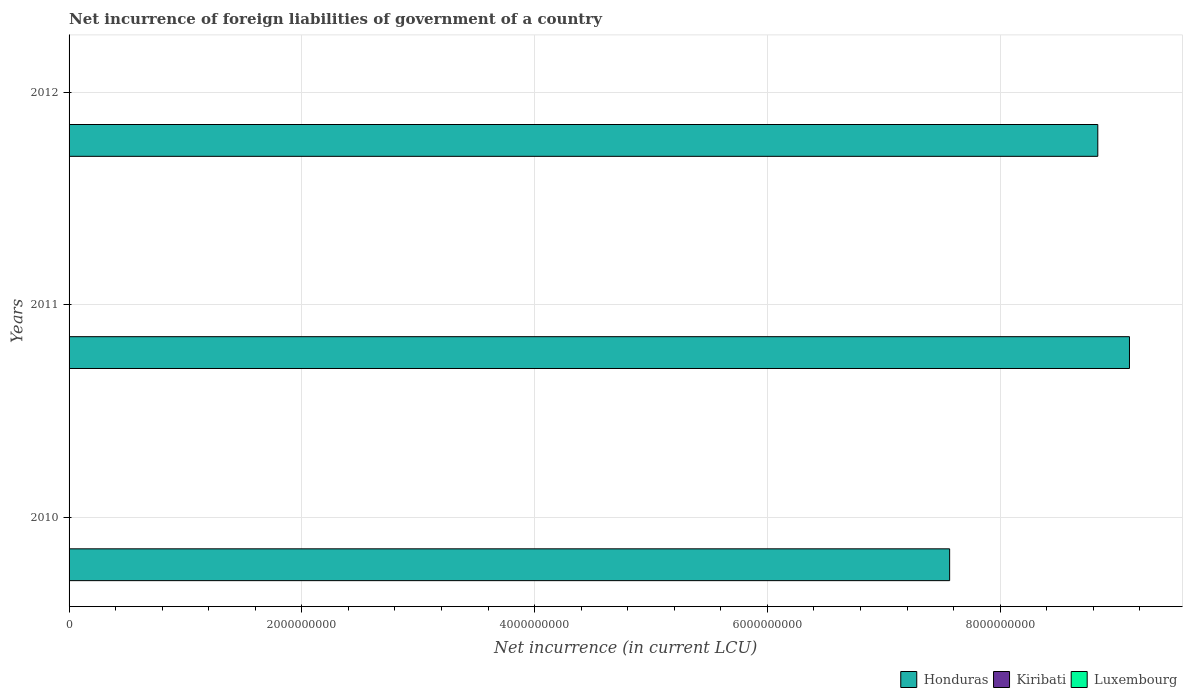How many different coloured bars are there?
Your answer should be very brief. 3. Are the number of bars on each tick of the Y-axis equal?
Provide a succinct answer. Yes. How many bars are there on the 3rd tick from the top?
Keep it short and to the point. 3. What is the net incurrence of foreign liabilities in Kiribati in 2012?
Offer a terse response. 3.40e+05. Across all years, what is the maximum net incurrence of foreign liabilities in Kiribati?
Keep it short and to the point. 3.50e+05. Across all years, what is the minimum net incurrence of foreign liabilities in Kiribati?
Provide a short and direct response. 2.02e+05. In which year was the net incurrence of foreign liabilities in Luxembourg maximum?
Offer a terse response. 2011. What is the total net incurrence of foreign liabilities in Luxembourg in the graph?
Give a very brief answer. 9.31e+06. What is the difference between the net incurrence of foreign liabilities in Honduras in 2010 and that in 2012?
Offer a terse response. -1.27e+09. What is the difference between the net incurrence of foreign liabilities in Honduras in 2010 and the net incurrence of foreign liabilities in Kiribati in 2011?
Keep it short and to the point. 7.57e+09. What is the average net incurrence of foreign liabilities in Luxembourg per year?
Your answer should be compact. 3.10e+06. In the year 2012, what is the difference between the net incurrence of foreign liabilities in Kiribati and net incurrence of foreign liabilities in Luxembourg?
Provide a short and direct response. -2.82e+06. What is the ratio of the net incurrence of foreign liabilities in Kiribati in 2011 to that in 2012?
Your response must be concise. 1.03. Is the net incurrence of foreign liabilities in Kiribati in 2011 less than that in 2012?
Give a very brief answer. No. Is the difference between the net incurrence of foreign liabilities in Kiribati in 2010 and 2011 greater than the difference between the net incurrence of foreign liabilities in Luxembourg in 2010 and 2011?
Offer a very short reply. Yes. What is the difference between the highest and the second highest net incurrence of foreign liabilities in Honduras?
Your answer should be very brief. 2.72e+08. What is the difference between the highest and the lowest net incurrence of foreign liabilities in Kiribati?
Provide a succinct answer. 1.48e+05. In how many years, is the net incurrence of foreign liabilities in Kiribati greater than the average net incurrence of foreign liabilities in Kiribati taken over all years?
Offer a very short reply. 2. Is the sum of the net incurrence of foreign liabilities in Kiribati in 2010 and 2011 greater than the maximum net incurrence of foreign liabilities in Honduras across all years?
Keep it short and to the point. No. What does the 1st bar from the top in 2011 represents?
Offer a very short reply. Luxembourg. What does the 3rd bar from the bottom in 2012 represents?
Keep it short and to the point. Luxembourg. What is the difference between two consecutive major ticks on the X-axis?
Provide a succinct answer. 2.00e+09. Are the values on the major ticks of X-axis written in scientific E-notation?
Your answer should be very brief. No. Does the graph contain any zero values?
Your response must be concise. No. How many legend labels are there?
Ensure brevity in your answer.  3. How are the legend labels stacked?
Make the answer very short. Horizontal. What is the title of the graph?
Make the answer very short. Net incurrence of foreign liabilities of government of a country. Does "Cyprus" appear as one of the legend labels in the graph?
Your answer should be very brief. No. What is the label or title of the X-axis?
Provide a short and direct response. Net incurrence (in current LCU). What is the label or title of the Y-axis?
Keep it short and to the point. Years. What is the Net incurrence (in current LCU) of Honduras in 2010?
Give a very brief answer. 7.57e+09. What is the Net incurrence (in current LCU) in Kiribati in 2010?
Provide a succinct answer. 2.02e+05. What is the Net incurrence (in current LCU) of Honduras in 2011?
Make the answer very short. 9.11e+09. What is the Net incurrence (in current LCU) of Kiribati in 2011?
Provide a short and direct response. 3.50e+05. What is the Net incurrence (in current LCU) in Luxembourg in 2011?
Ensure brevity in your answer.  3.16e+06. What is the Net incurrence (in current LCU) in Honduras in 2012?
Make the answer very short. 8.84e+09. What is the Net incurrence (in current LCU) in Kiribati in 2012?
Give a very brief answer. 3.40e+05. What is the Net incurrence (in current LCU) in Luxembourg in 2012?
Keep it short and to the point. 3.16e+06. Across all years, what is the maximum Net incurrence (in current LCU) in Honduras?
Offer a very short reply. 9.11e+09. Across all years, what is the maximum Net incurrence (in current LCU) in Kiribati?
Offer a very short reply. 3.50e+05. Across all years, what is the maximum Net incurrence (in current LCU) of Luxembourg?
Make the answer very short. 3.16e+06. Across all years, what is the minimum Net incurrence (in current LCU) in Honduras?
Provide a short and direct response. 7.57e+09. Across all years, what is the minimum Net incurrence (in current LCU) of Kiribati?
Keep it short and to the point. 2.02e+05. Across all years, what is the minimum Net incurrence (in current LCU) of Luxembourg?
Your answer should be very brief. 3.00e+06. What is the total Net incurrence (in current LCU) of Honduras in the graph?
Offer a very short reply. 2.55e+1. What is the total Net incurrence (in current LCU) in Kiribati in the graph?
Ensure brevity in your answer.  8.92e+05. What is the total Net incurrence (in current LCU) in Luxembourg in the graph?
Your answer should be very brief. 9.31e+06. What is the difference between the Net incurrence (in current LCU) of Honduras in 2010 and that in 2011?
Your answer should be compact. -1.55e+09. What is the difference between the Net incurrence (in current LCU) of Kiribati in 2010 and that in 2011?
Offer a very short reply. -1.48e+05. What is the difference between the Net incurrence (in current LCU) of Luxembourg in 2010 and that in 2011?
Provide a short and direct response. -1.57e+05. What is the difference between the Net incurrence (in current LCU) of Honduras in 2010 and that in 2012?
Your answer should be very brief. -1.27e+09. What is the difference between the Net incurrence (in current LCU) in Kiribati in 2010 and that in 2012?
Offer a terse response. -1.37e+05. What is the difference between the Net incurrence (in current LCU) in Luxembourg in 2010 and that in 2012?
Ensure brevity in your answer.  -1.57e+05. What is the difference between the Net incurrence (in current LCU) of Honduras in 2011 and that in 2012?
Ensure brevity in your answer.  2.72e+08. What is the difference between the Net incurrence (in current LCU) of Kiribati in 2011 and that in 2012?
Your answer should be compact. 1.02e+04. What is the difference between the Net incurrence (in current LCU) in Luxembourg in 2011 and that in 2012?
Your answer should be very brief. 0. What is the difference between the Net incurrence (in current LCU) in Honduras in 2010 and the Net incurrence (in current LCU) in Kiribati in 2011?
Provide a short and direct response. 7.57e+09. What is the difference between the Net incurrence (in current LCU) of Honduras in 2010 and the Net incurrence (in current LCU) of Luxembourg in 2011?
Offer a terse response. 7.56e+09. What is the difference between the Net incurrence (in current LCU) in Kiribati in 2010 and the Net incurrence (in current LCU) in Luxembourg in 2011?
Offer a terse response. -2.95e+06. What is the difference between the Net incurrence (in current LCU) in Honduras in 2010 and the Net incurrence (in current LCU) in Kiribati in 2012?
Ensure brevity in your answer.  7.57e+09. What is the difference between the Net incurrence (in current LCU) in Honduras in 2010 and the Net incurrence (in current LCU) in Luxembourg in 2012?
Ensure brevity in your answer.  7.56e+09. What is the difference between the Net incurrence (in current LCU) of Kiribati in 2010 and the Net incurrence (in current LCU) of Luxembourg in 2012?
Provide a succinct answer. -2.95e+06. What is the difference between the Net incurrence (in current LCU) of Honduras in 2011 and the Net incurrence (in current LCU) of Kiribati in 2012?
Give a very brief answer. 9.11e+09. What is the difference between the Net incurrence (in current LCU) in Honduras in 2011 and the Net incurrence (in current LCU) in Luxembourg in 2012?
Keep it short and to the point. 9.11e+09. What is the difference between the Net incurrence (in current LCU) of Kiribati in 2011 and the Net incurrence (in current LCU) of Luxembourg in 2012?
Give a very brief answer. -2.81e+06. What is the average Net incurrence (in current LCU) of Honduras per year?
Offer a very short reply. 8.51e+09. What is the average Net incurrence (in current LCU) in Kiribati per year?
Give a very brief answer. 2.97e+05. What is the average Net incurrence (in current LCU) of Luxembourg per year?
Offer a very short reply. 3.10e+06. In the year 2010, what is the difference between the Net incurrence (in current LCU) in Honduras and Net incurrence (in current LCU) in Kiribati?
Ensure brevity in your answer.  7.57e+09. In the year 2010, what is the difference between the Net incurrence (in current LCU) in Honduras and Net incurrence (in current LCU) in Luxembourg?
Give a very brief answer. 7.56e+09. In the year 2010, what is the difference between the Net incurrence (in current LCU) of Kiribati and Net incurrence (in current LCU) of Luxembourg?
Your answer should be compact. -2.80e+06. In the year 2011, what is the difference between the Net incurrence (in current LCU) in Honduras and Net incurrence (in current LCU) in Kiribati?
Make the answer very short. 9.11e+09. In the year 2011, what is the difference between the Net incurrence (in current LCU) in Honduras and Net incurrence (in current LCU) in Luxembourg?
Give a very brief answer. 9.11e+09. In the year 2011, what is the difference between the Net incurrence (in current LCU) in Kiribati and Net incurrence (in current LCU) in Luxembourg?
Offer a terse response. -2.81e+06. In the year 2012, what is the difference between the Net incurrence (in current LCU) in Honduras and Net incurrence (in current LCU) in Kiribati?
Offer a very short reply. 8.84e+09. In the year 2012, what is the difference between the Net incurrence (in current LCU) of Honduras and Net incurrence (in current LCU) of Luxembourg?
Offer a terse response. 8.84e+09. In the year 2012, what is the difference between the Net incurrence (in current LCU) of Kiribati and Net incurrence (in current LCU) of Luxembourg?
Make the answer very short. -2.82e+06. What is the ratio of the Net incurrence (in current LCU) of Honduras in 2010 to that in 2011?
Give a very brief answer. 0.83. What is the ratio of the Net incurrence (in current LCU) of Kiribati in 2010 to that in 2011?
Give a very brief answer. 0.58. What is the ratio of the Net incurrence (in current LCU) of Luxembourg in 2010 to that in 2011?
Offer a very short reply. 0.95. What is the ratio of the Net incurrence (in current LCU) in Honduras in 2010 to that in 2012?
Offer a terse response. 0.86. What is the ratio of the Net incurrence (in current LCU) in Kiribati in 2010 to that in 2012?
Provide a succinct answer. 0.6. What is the ratio of the Net incurrence (in current LCU) of Luxembourg in 2010 to that in 2012?
Your answer should be compact. 0.95. What is the ratio of the Net incurrence (in current LCU) in Honduras in 2011 to that in 2012?
Your answer should be compact. 1.03. What is the ratio of the Net incurrence (in current LCU) in Kiribati in 2011 to that in 2012?
Your answer should be compact. 1.03. What is the ratio of the Net incurrence (in current LCU) of Luxembourg in 2011 to that in 2012?
Your response must be concise. 1. What is the difference between the highest and the second highest Net incurrence (in current LCU) in Honduras?
Your answer should be very brief. 2.72e+08. What is the difference between the highest and the second highest Net incurrence (in current LCU) in Kiribati?
Provide a short and direct response. 1.02e+04. What is the difference between the highest and the second highest Net incurrence (in current LCU) in Luxembourg?
Your response must be concise. 0. What is the difference between the highest and the lowest Net incurrence (in current LCU) in Honduras?
Ensure brevity in your answer.  1.55e+09. What is the difference between the highest and the lowest Net incurrence (in current LCU) of Kiribati?
Your response must be concise. 1.48e+05. What is the difference between the highest and the lowest Net incurrence (in current LCU) in Luxembourg?
Provide a short and direct response. 1.57e+05. 